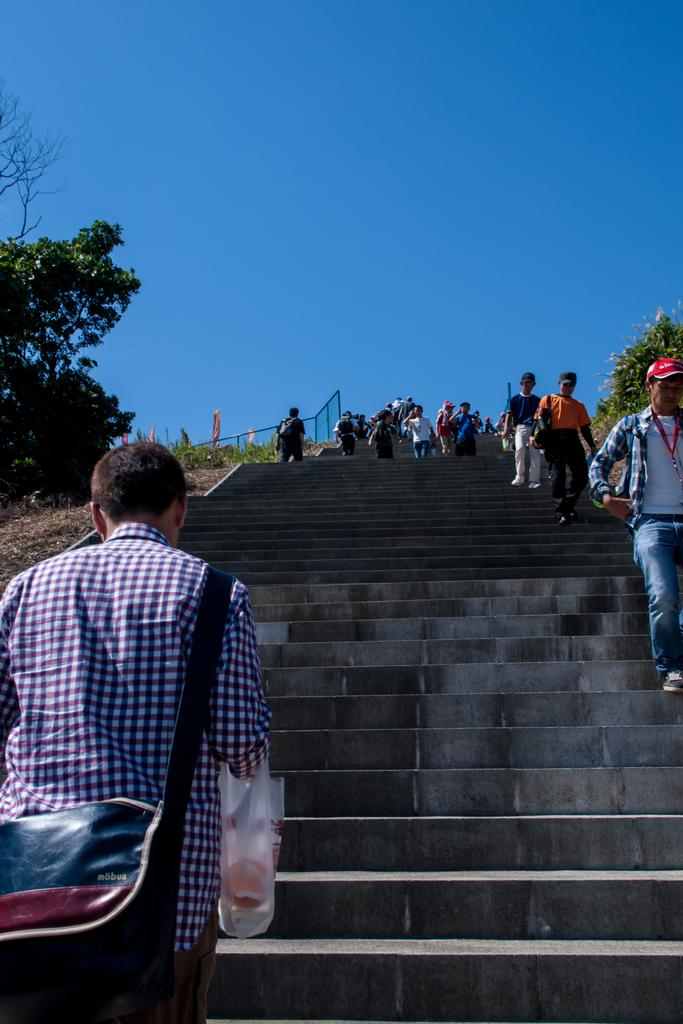What is the main feature of the image? There are many steps in the image. What are some people doing in relation to the steps? Some people are getting down the steps, while others are getting up the stairs. What can be seen in the surroundings of the steps? There are trees around the stairs. What type of copy machine can be seen on the steps in the image? There is no copy machine present in the image; it features steps with people going up and down. Are there any bushes visible in the image? The provided facts do not mention bushes, and they are not visible in the image. 